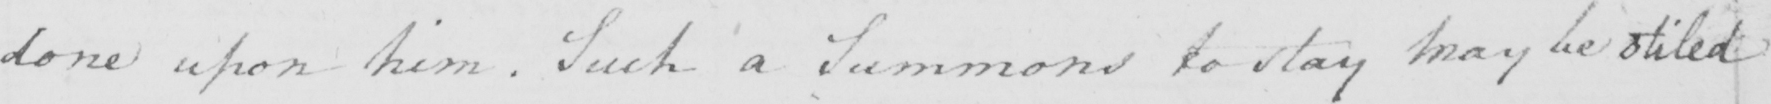What is written in this line of handwriting? done upon him . Such a Summons to stay may be stiled 